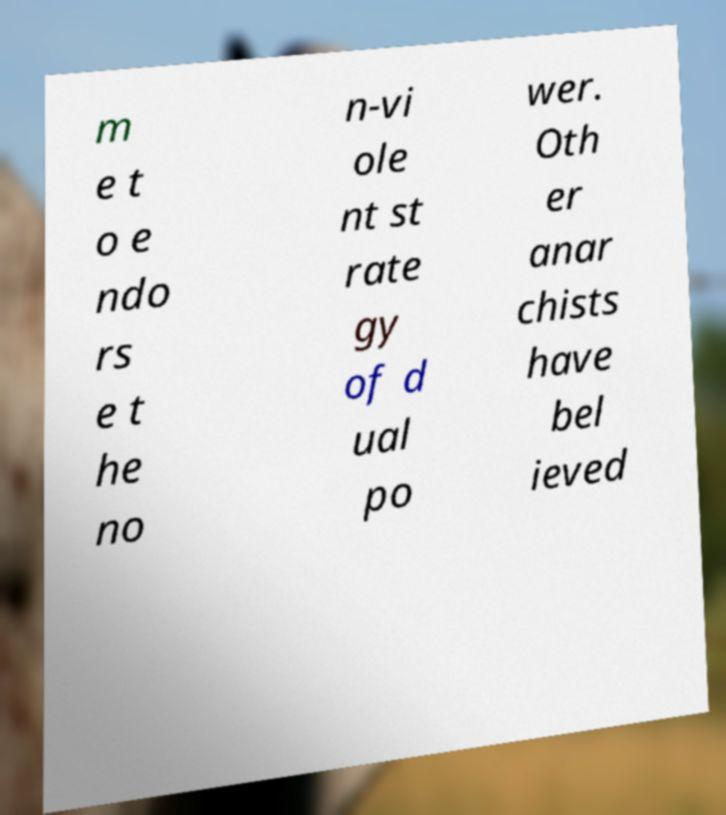For documentation purposes, I need the text within this image transcribed. Could you provide that? m e t o e ndo rs e t he no n-vi ole nt st rate gy of d ual po wer. Oth er anar chists have bel ieved 